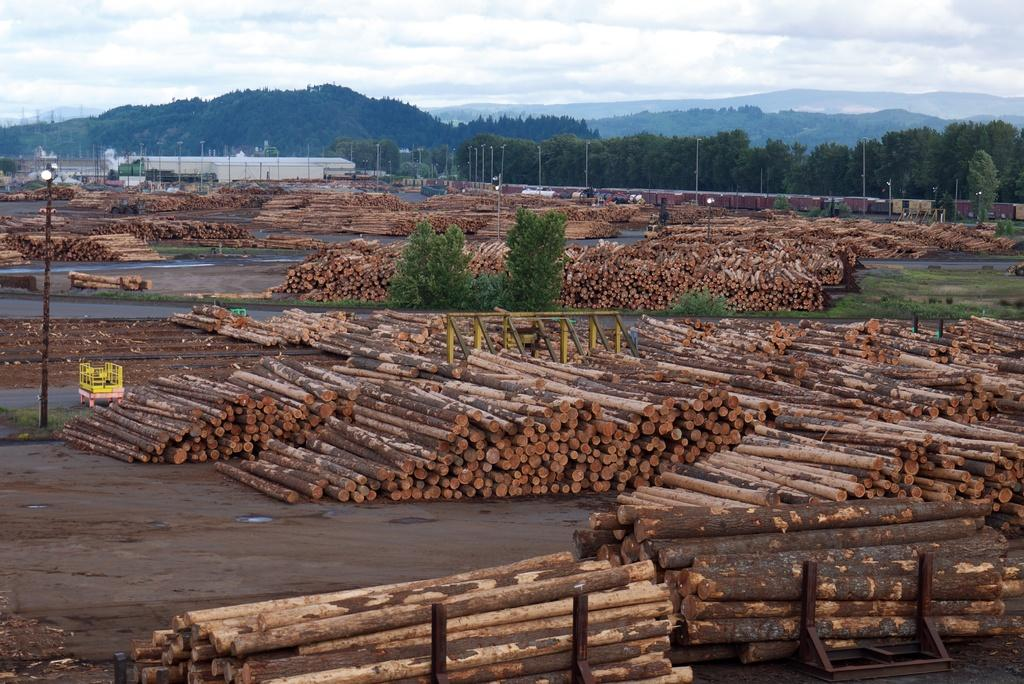What type of objects are on the ground in the image? There are groups of wooden items on the ground. What can be seen in the background of the image? There are trees, poles, sheds, and mountains in the background. What is visible in the sky in the image? There are clouds in the sky. What type of song is being played by the basketball in the image? There is no basketball present in the image, and therefore no song can be associated with it. 